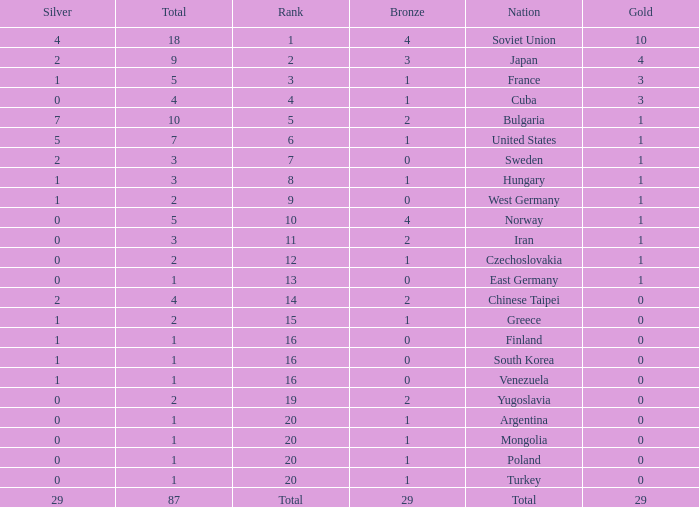Which rank has 1 silver medal and more than 1 gold medal? 3.0. 